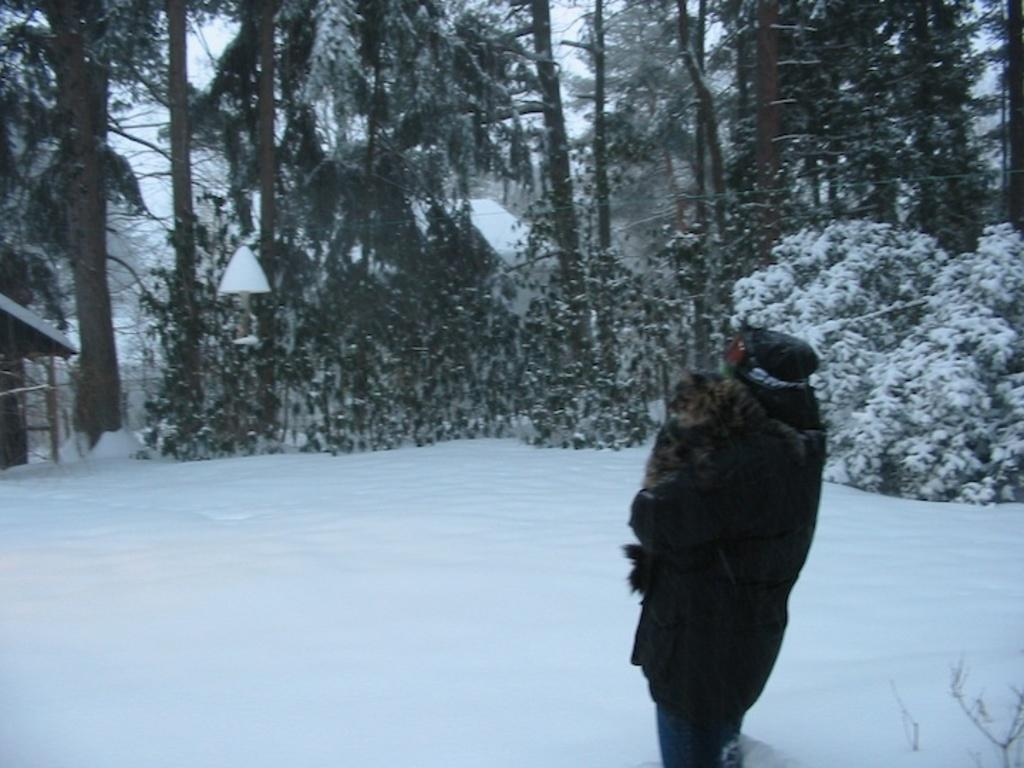What is the main subject of the image? There is a person standing in the image. What is the terrain like where the person is standing? The person is standing on icy land. What can be seen in the background of the image? There are trees and plants in the background of the image. How many chairs are visible in the image? There are no chairs present in the image. What type of collar is the person wearing in the image? The person in the image is not wearing a collar, as they are not depicted with any clothing or accessories. 